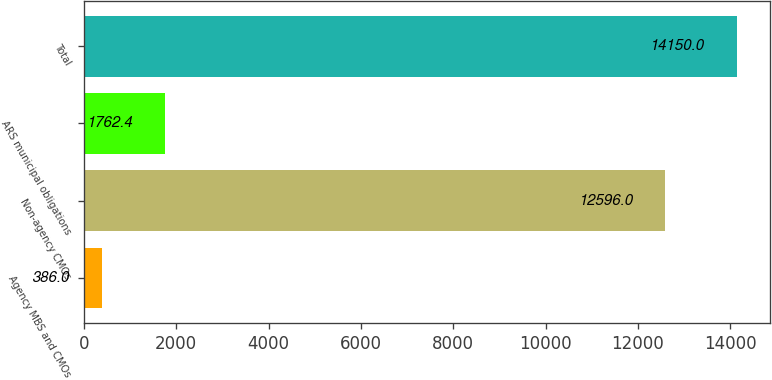Convert chart. <chart><loc_0><loc_0><loc_500><loc_500><bar_chart><fcel>Agency MBS and CMOs<fcel>Non-agency CMOs<fcel>ARS municipal obligations<fcel>Total<nl><fcel>386<fcel>12596<fcel>1762.4<fcel>14150<nl></chart> 